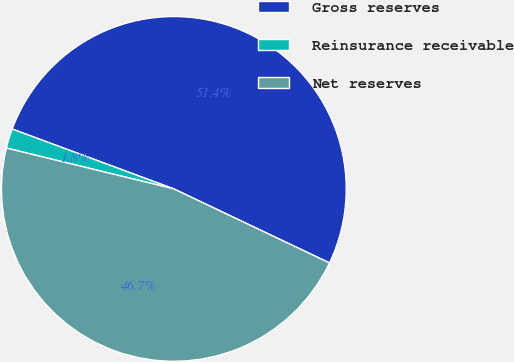Convert chart to OTSL. <chart><loc_0><loc_0><loc_500><loc_500><pie_chart><fcel>Gross reserves<fcel>Reinsurance receivable<fcel>Net reserves<nl><fcel>51.42%<fcel>1.84%<fcel>46.74%<nl></chart> 